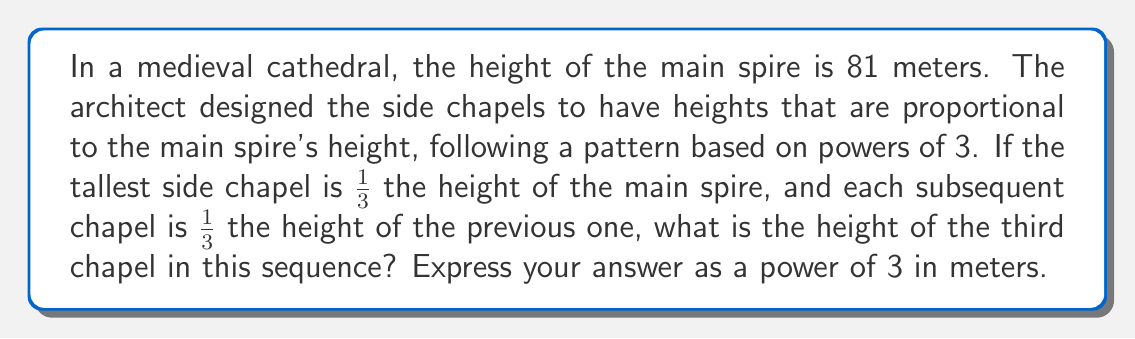Give your solution to this math problem. Let's approach this step-by-step:

1) First, let's establish the heights of the chapels in the sequence:

   Main spire: 81 meters = $3^4$ meters
   
   First chapel: $\frac{1}{3}$ of 81 meters = 27 meters = $3^3$ meters
   
   Second chapel: $\frac{1}{3}$ of 27 meters = 9 meters = $3^2$ meters
   
   Third chapel: $\frac{1}{3}$ of 9 meters = 3 meters = $3^1$ meters

2) We can see a pattern forming. Each time we move to the next chapel, the exponent of 3 decreases by 1.

3) We can express this mathematically:

   Height of nth chapel = $81 \cdot (\frac{1}{3})^{n-1}$ meters, where n is the position of the chapel in the sequence.

4) For the third chapel, n = 3:

   Height of third chapel = $81 \cdot (\frac{1}{3})^{3-1}$ = $81 \cdot (\frac{1}{3})^2$ = $81 \cdot \frac{1}{9}$ = 9 meters

5) We need to express this as a power of 3:

   9 = $3^2$

Therefore, the height of the third chapel is $3^2$ meters.
Answer: $3^2$ meters 